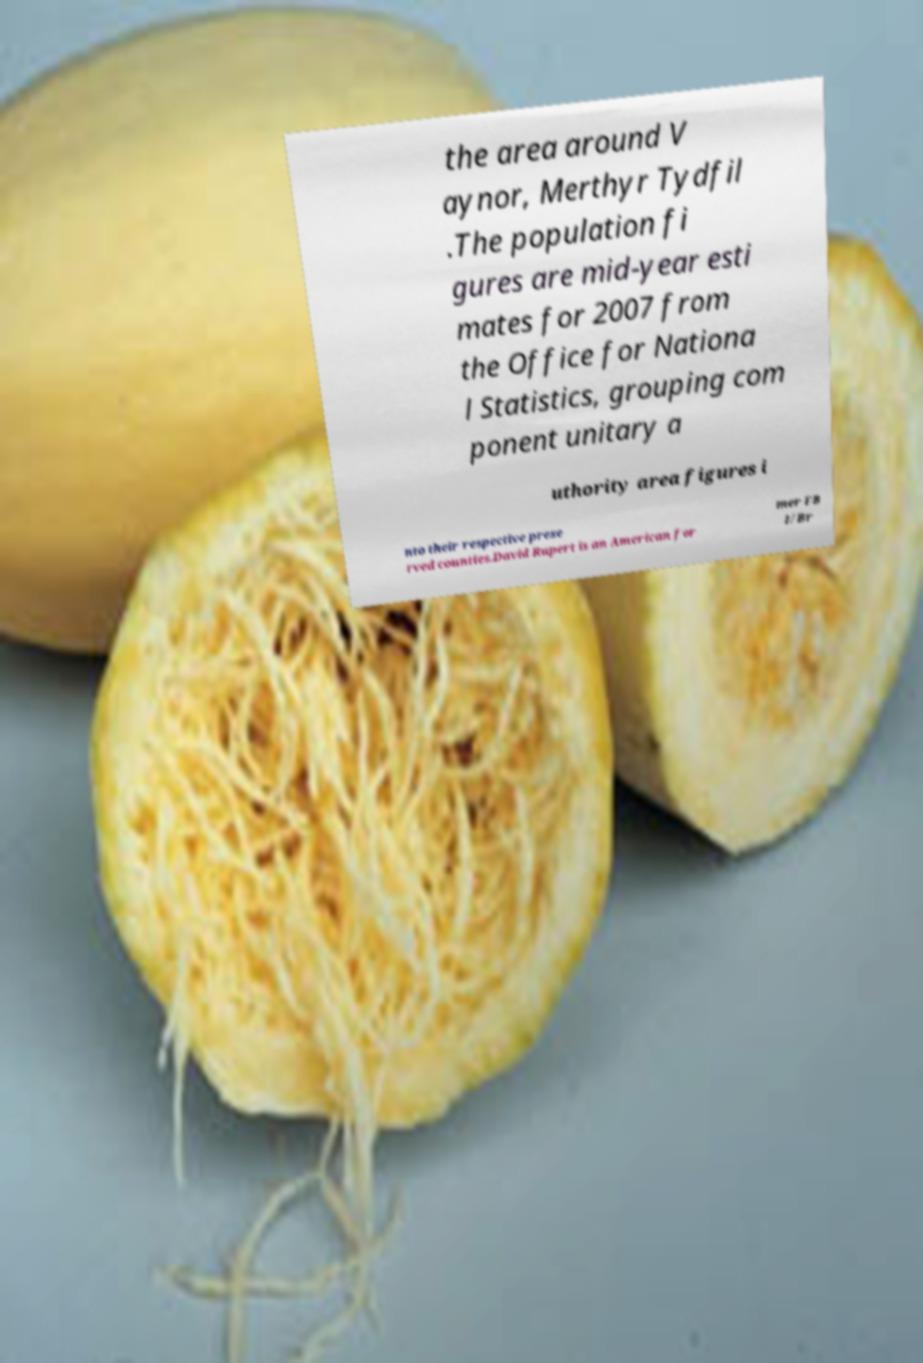There's text embedded in this image that I need extracted. Can you transcribe it verbatim? the area around V aynor, Merthyr Tydfil .The population fi gures are mid-year esti mates for 2007 from the Office for Nationa l Statistics, grouping com ponent unitary a uthority area figures i nto their respective prese rved counties.David Rupert is an American for mer FB I/Br 